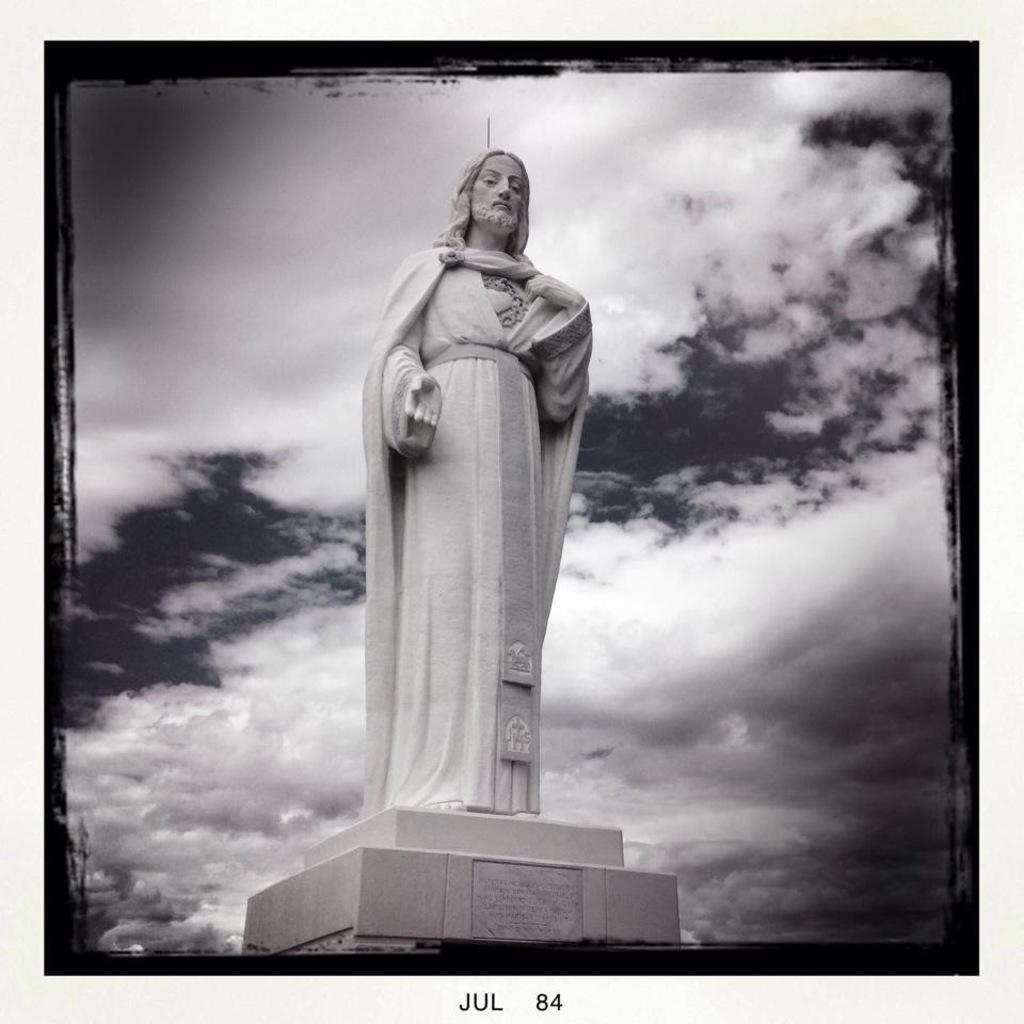Could you give a brief overview of what you see in this image? This is an edited image where we can see a statue in the middle of this image and the cloudy sky is in the background. We can see text at the bottom of this image. 